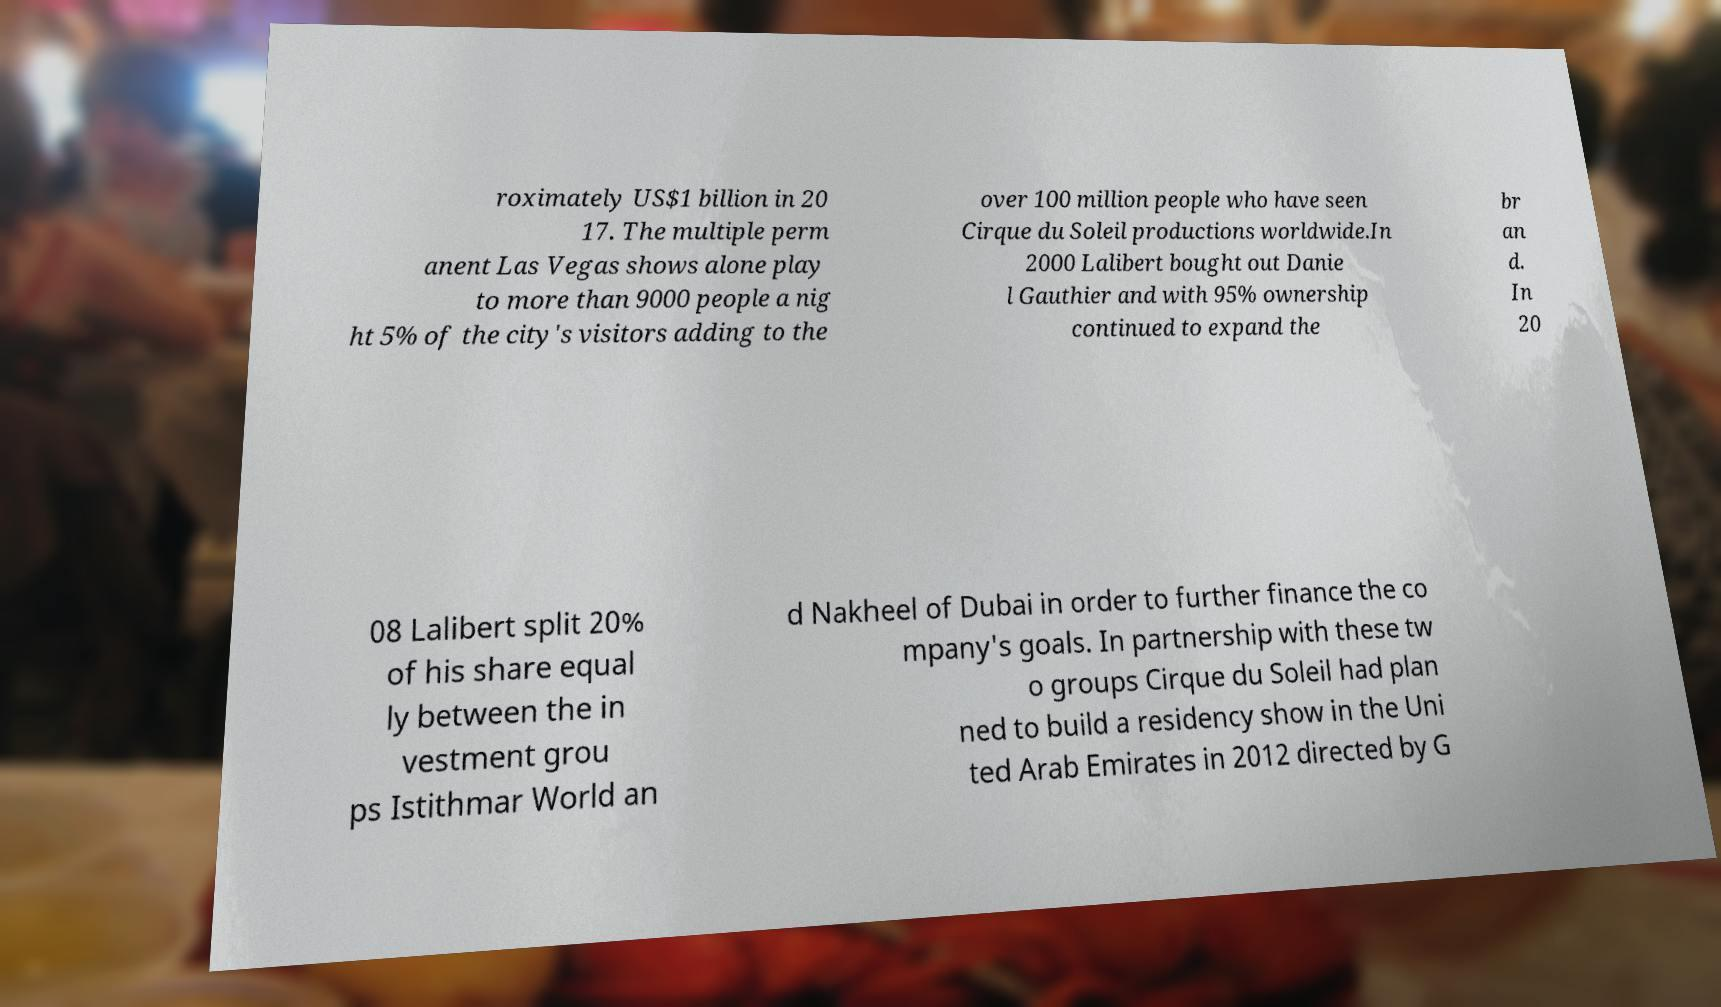Can you accurately transcribe the text from the provided image for me? roximately US$1 billion in 20 17. The multiple perm anent Las Vegas shows alone play to more than 9000 people a nig ht 5% of the city's visitors adding to the over 100 million people who have seen Cirque du Soleil productions worldwide.In 2000 Lalibert bought out Danie l Gauthier and with 95% ownership continued to expand the br an d. In 20 08 Lalibert split 20% of his share equal ly between the in vestment grou ps Istithmar World an d Nakheel of Dubai in order to further finance the co mpany's goals. In partnership with these tw o groups Cirque du Soleil had plan ned to build a residency show in the Uni ted Arab Emirates in 2012 directed by G 